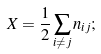<formula> <loc_0><loc_0><loc_500><loc_500>X = \frac { 1 } { 2 } \sum _ { i \neq j } n _ { i j } ;</formula> 